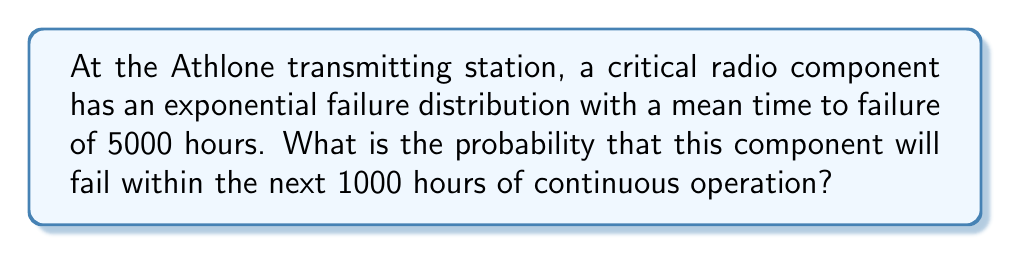Show me your answer to this math problem. Let's approach this step-by-step using reliability theory and exponential distributions:

1) In an exponential distribution, the failure rate λ (lambda) is the inverse of the mean time to failure. Here:

   $\lambda = \frac{1}{\text{mean time to failure}} = \frac{1}{5000}$ hours^(-1)

2) The cumulative distribution function (CDF) of an exponential distribution gives the probability of failure within a certain time t:

   $F(t) = 1 - e^{-\lambda t}$

3) We want to find the probability of failure within 1000 hours, so t = 1000:

   $P(\text{failure within 1000 hours}) = 1 - e^{-\lambda \cdot 1000}$

4) Substituting the value of λ:

   $P(\text{failure within 1000 hours}) = 1 - e^{-\frac{1}{5000} \cdot 1000}$

5) Simplifying:

   $P(\text{failure within 1000 hours}) = 1 - e^{-0.2}$

6) Calculating:

   $P(\text{failure within 1000 hours}) = 1 - 0.8187 = 0.1813$

Therefore, the probability that the component will fail within the next 1000 hours is approximately 0.1813 or 18.13%.
Answer: 0.1813 